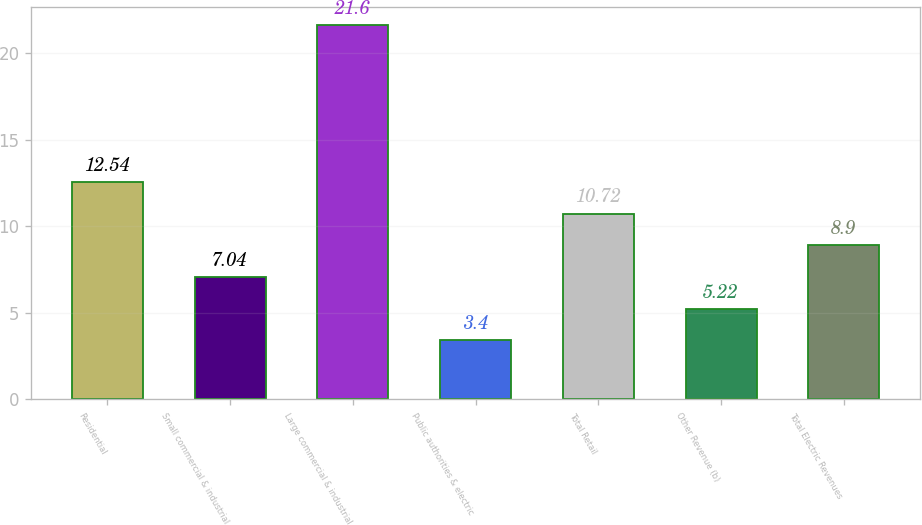Convert chart to OTSL. <chart><loc_0><loc_0><loc_500><loc_500><bar_chart><fcel>Residential<fcel>Small commercial & industrial<fcel>Large commercial & industrial<fcel>Public authorities & electric<fcel>Total Retail<fcel>Other Revenue (b)<fcel>Total Electric Revenues<nl><fcel>12.54<fcel>7.04<fcel>21.6<fcel>3.4<fcel>10.72<fcel>5.22<fcel>8.9<nl></chart> 